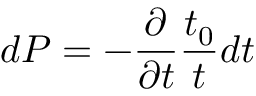<formula> <loc_0><loc_0><loc_500><loc_500>d P = - \frac { \partial } { \partial t } \frac { t _ { 0 } } { t } d t</formula> 